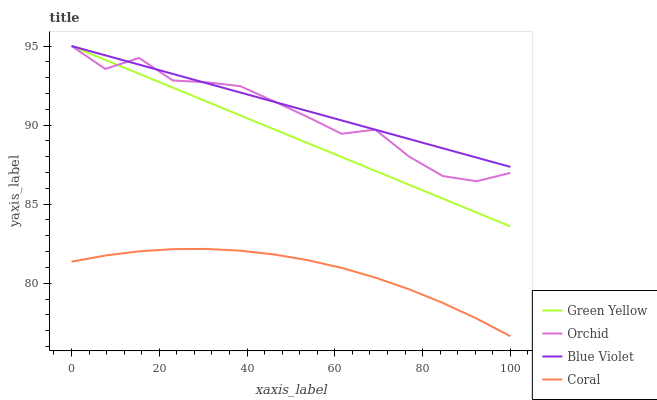Does Coral have the minimum area under the curve?
Answer yes or no. Yes. Does Blue Violet have the maximum area under the curve?
Answer yes or no. Yes. Does Green Yellow have the minimum area under the curve?
Answer yes or no. No. Does Green Yellow have the maximum area under the curve?
Answer yes or no. No. Is Green Yellow the smoothest?
Answer yes or no. Yes. Is Orchid the roughest?
Answer yes or no. Yes. Is Blue Violet the smoothest?
Answer yes or no. No. Is Blue Violet the roughest?
Answer yes or no. No. Does Coral have the lowest value?
Answer yes or no. Yes. Does Green Yellow have the lowest value?
Answer yes or no. No. Does Orchid have the highest value?
Answer yes or no. Yes. Is Coral less than Blue Violet?
Answer yes or no. Yes. Is Blue Violet greater than Coral?
Answer yes or no. Yes. Does Blue Violet intersect Green Yellow?
Answer yes or no. Yes. Is Blue Violet less than Green Yellow?
Answer yes or no. No. Is Blue Violet greater than Green Yellow?
Answer yes or no. No. Does Coral intersect Blue Violet?
Answer yes or no. No. 